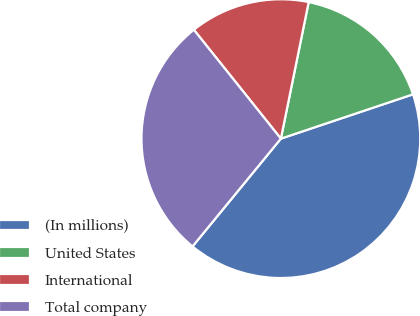<chart> <loc_0><loc_0><loc_500><loc_500><pie_chart><fcel>(In millions)<fcel>United States<fcel>International<fcel>Total company<nl><fcel>41.08%<fcel>16.65%<fcel>13.93%<fcel>28.34%<nl></chart> 